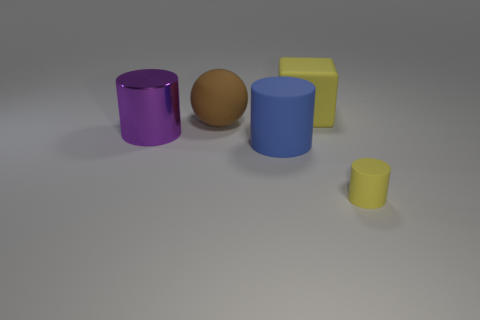Add 1 red spheres. How many objects exist? 6 Subtract all blue cylinders. How many cylinders are left? 2 Subtract all large cylinders. How many cylinders are left? 1 Subtract 0 cyan cubes. How many objects are left? 5 Subtract all cylinders. How many objects are left? 2 Subtract 2 cylinders. How many cylinders are left? 1 Subtract all gray cylinders. Subtract all cyan spheres. How many cylinders are left? 3 Subtract all red cubes. How many purple spheres are left? 0 Subtract all large balls. Subtract all big purple cylinders. How many objects are left? 3 Add 4 small yellow rubber cylinders. How many small yellow rubber cylinders are left? 5 